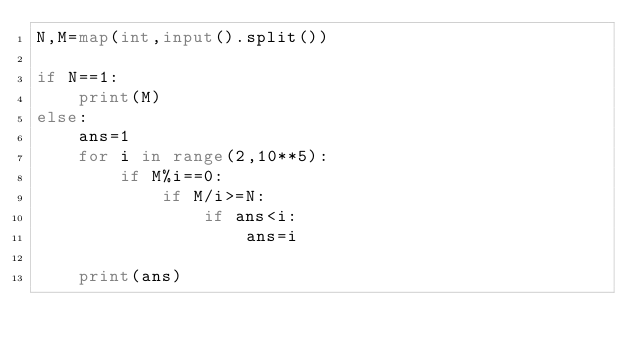<code> <loc_0><loc_0><loc_500><loc_500><_Python_>N,M=map(int,input().split())

if N==1:
    print(M)
else:
    ans=1
    for i in range(2,10**5):
        if M%i==0:
            if M/i>=N:
                if ans<i:
                    ans=i
                
    print(ans)</code> 